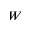Convert formula to latex. <formula><loc_0><loc_0><loc_500><loc_500>W</formula> 